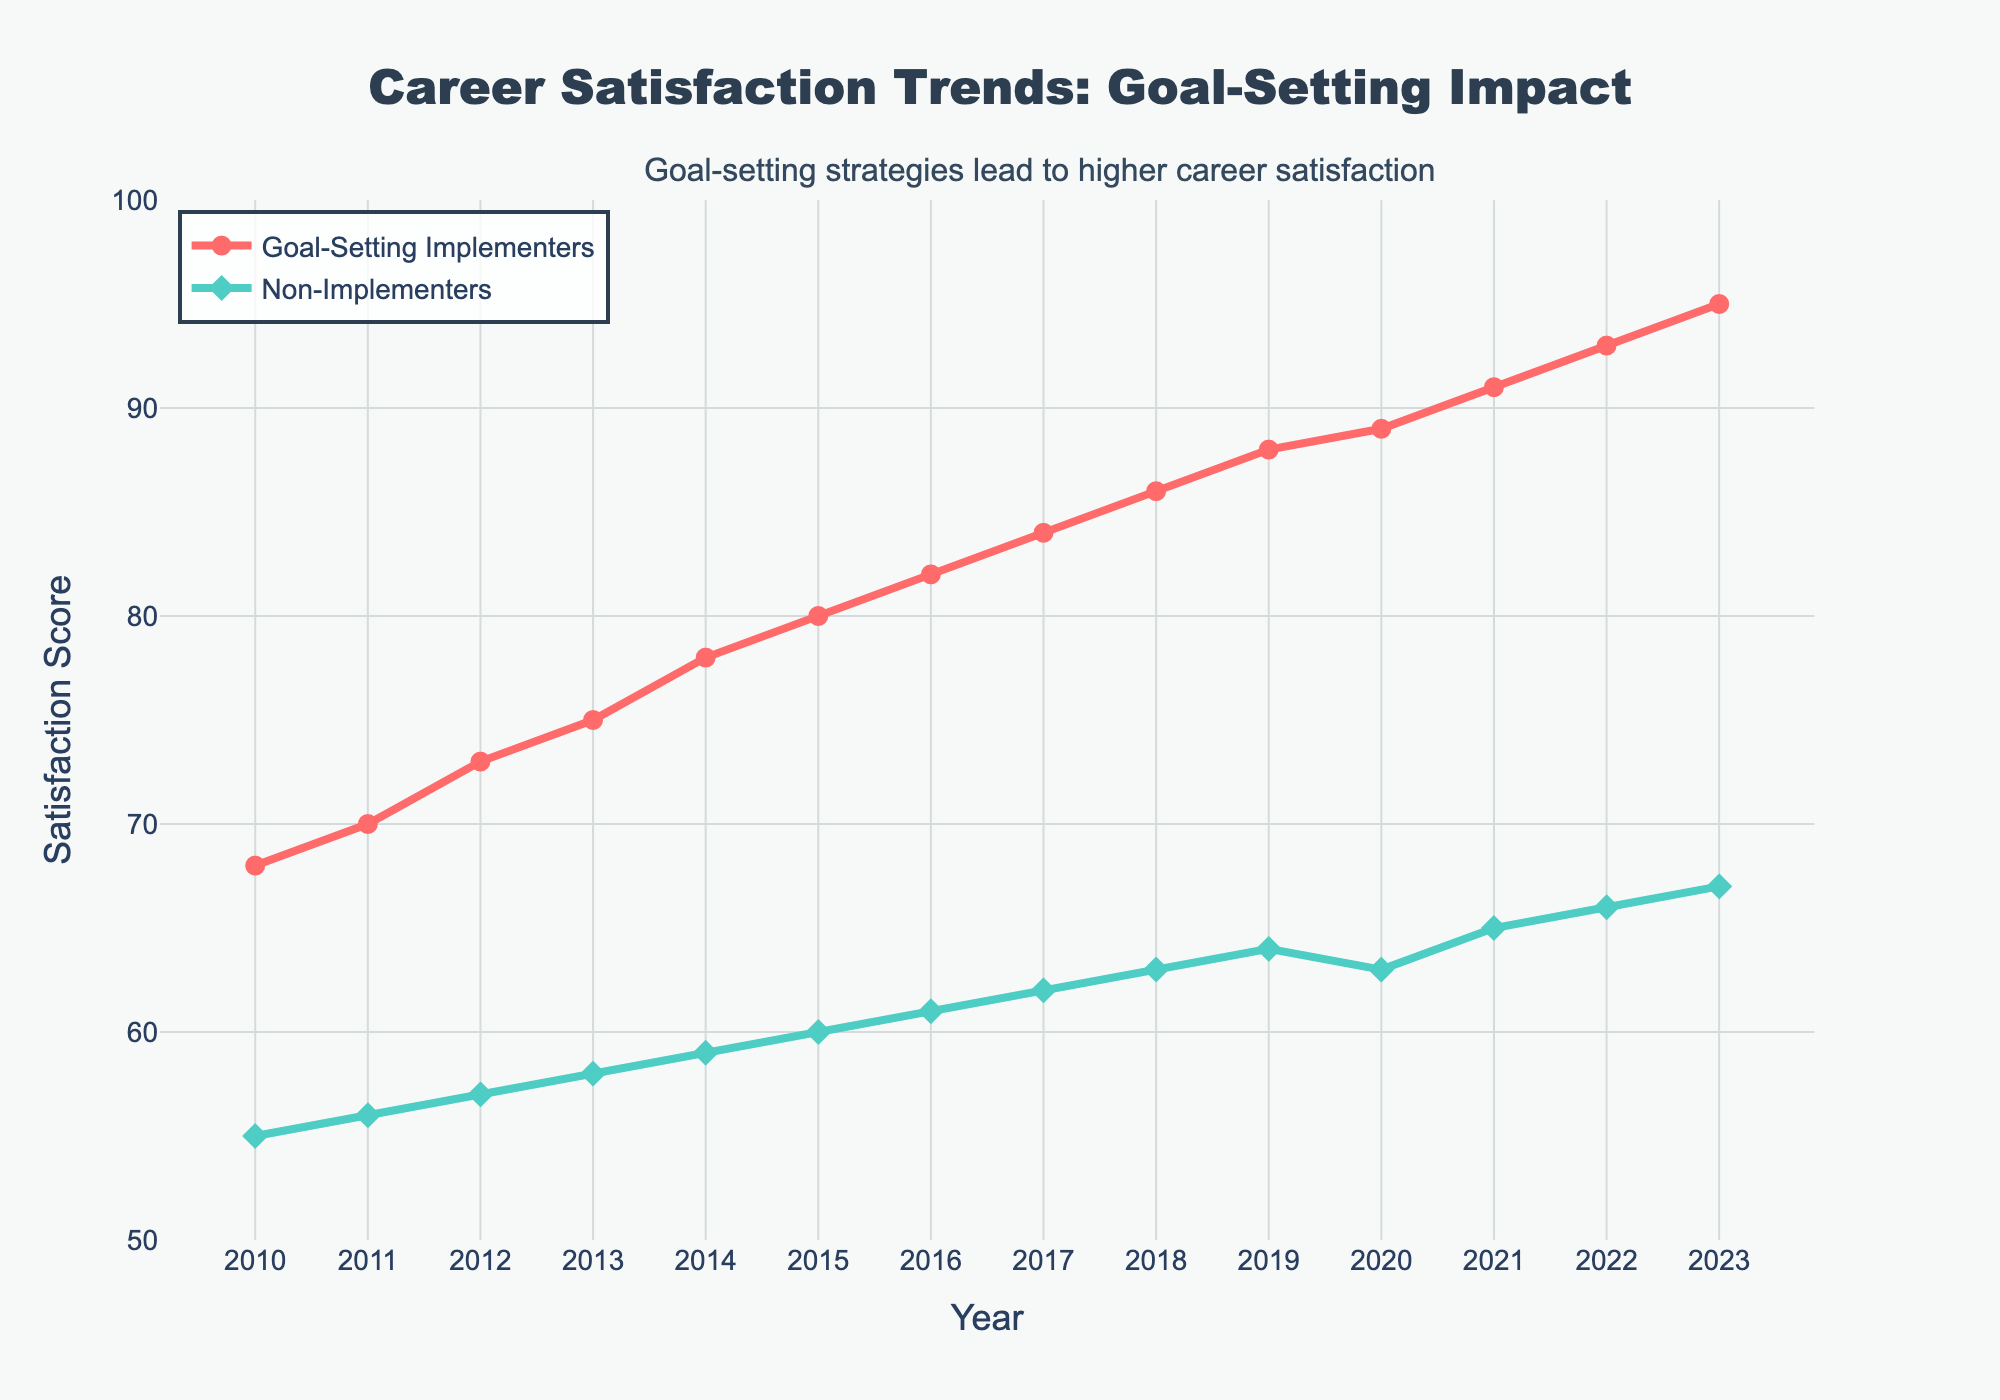How does the career satisfaction trend for Goal-Setting Implementers compare to Non-Implementers over the given period? Both groups show an increasing trend. However, the satisfaction scores for Goal-Setting Implementers consistently improve at a faster rate and are higher overall compared to Non-Implementers. This suggests that implementing goal-setting strategies is associated with greater career satisfaction over time.
Answer: Goal-Setting Implementers have higher increasing trends What is the difference in satisfaction scores between Goal-Setting Implementers and Non-Implementers in 2023? In 2023, the satisfaction score for Goal-Setting Implementers is 95 and for Non-Implementers is 67. The difference is 95 - 67 = 28.
Answer: 28 During which year did Goal-Setting Implementers achieve a satisfaction score of 80? By closely observing the trend for Goal-Setting Implementers, they achieve a satisfaction score of 80 in the year 2015.
Answer: 2015 Compare the satisfaction score of Non-Implementers in 2010 and 2023. How much has it increased? In 2010, the satisfaction score for Non-Implementers was 55. By 2023, it increased to 67. The increase is 67 - 55 = 12.
Answer: 12 What is the average satisfaction score for Goal-Setting Implementers over the entire period? Sum up the satisfaction scores for Goal-Setting Implementers across all years (68+70+73+75+78+80+82+84+86+88+89+91+93+95) = 1142. There are 14 years, so the average is 1142 / 14 = 81.57.
Answer: 81.57 Which year shows a decrease in satisfaction for Non-Implementers, and what are the respective scores? Compare the satisfaction scores year by year for Non-Implementers. The year 2020 shows a decrease with scores going from 64 in 2019 to 63 in 2020.
Answer: 2020; 64 to 63 What is the overall trend in satisfaction scores for both groups over the period? Both Goal-Setting Implementers and Non-Implementers show an increasing trend in satisfaction scores over the period. Goal-Setting Implementers see a steeper upward trend, reaching higher satisfaction scores than Non-Implementers.
Answer: Increasing for both, steeper for Implementers How much did the satisfaction of Goal-Setting Implementers increase from 2010 to 2023? In 2010, the satisfaction score for Goal-Setting Implementers was 68, and in 2023 it is 95. The increase is 95 - 68 = 27.
Answer: 27 Which group had a higher satisfaction score in 2015, and by how much? In 2015, the satisfaction score for Goal-Setting Implementers is 80, while for Non-Implementers it's 60. The difference is 80 - 60 = 20.
Answer: Goal-Setting Implementers by 20 